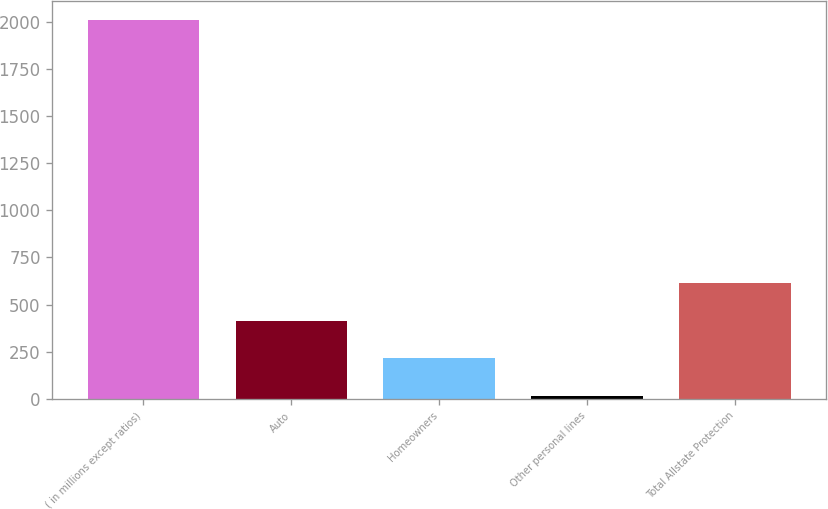<chart> <loc_0><loc_0><loc_500><loc_500><bar_chart><fcel>( in millions except ratios)<fcel>Auto<fcel>Homeowners<fcel>Other personal lines<fcel>Total Allstate Protection<nl><fcel>2010<fcel>414<fcel>214.5<fcel>15<fcel>613.5<nl></chart> 